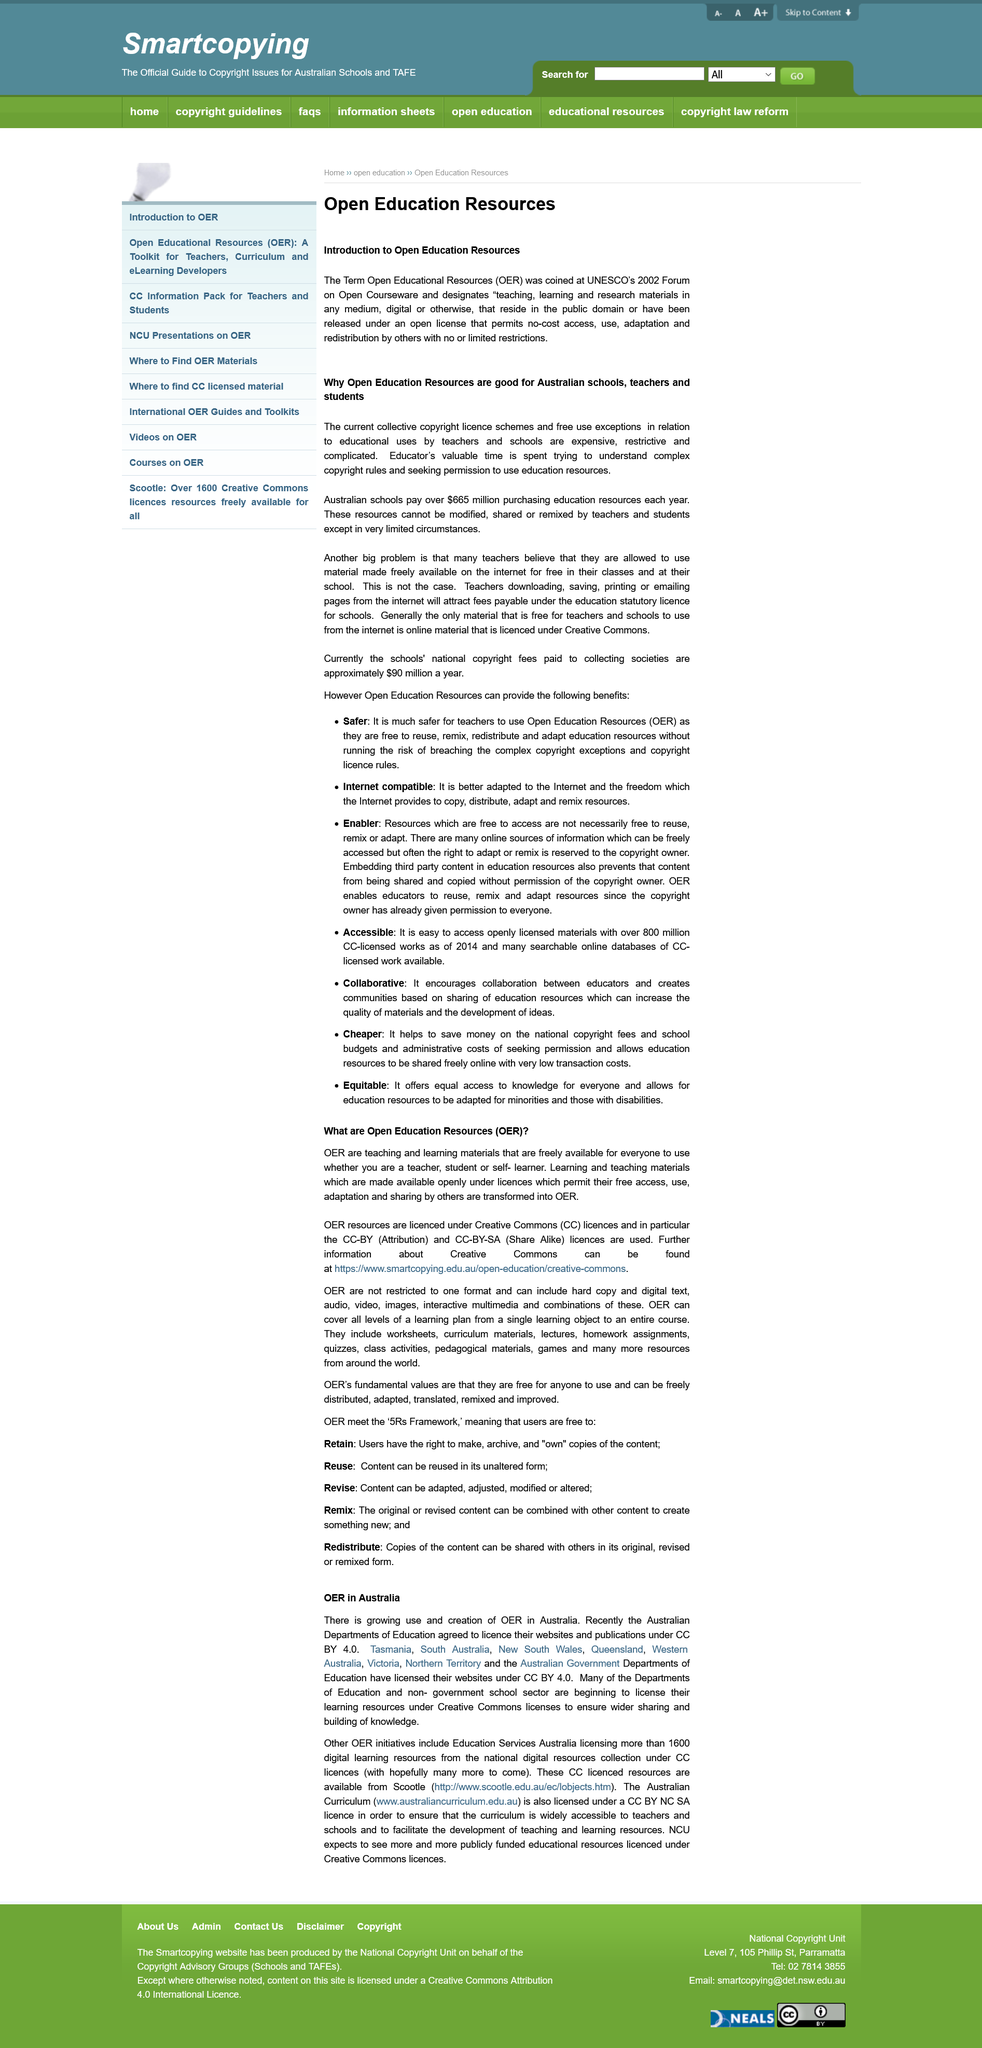Identify some key points in this picture. Open Education Resources, commonly referred to as OER, refers to educational materials that are made available to the public for free and can be used, modified, and shared without restriction. Open Education Resources are beneficial for the schools, teachers, and students in Australia and for the continent of Australia. The term "OER" was first introduced by UNESCO at its 2002 Forum on Open Courseware. 